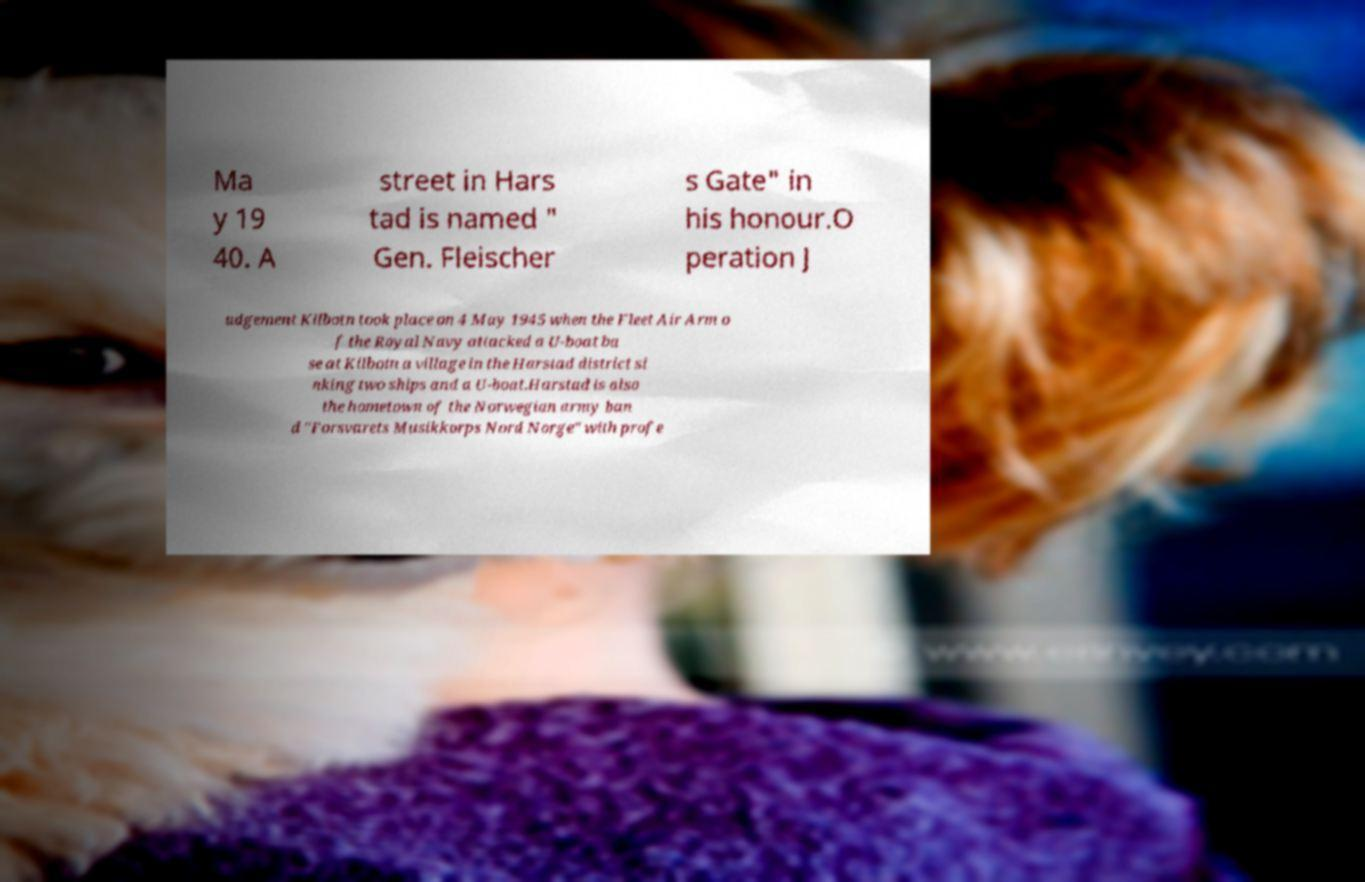Can you accurately transcribe the text from the provided image for me? Ma y 19 40. A street in Hars tad is named " Gen. Fleischer s Gate" in his honour.O peration J udgement Kilbotn took place on 4 May 1945 when the Fleet Air Arm o f the Royal Navy attacked a U-boat ba se at Kilbotn a village in the Harstad district si nking two ships and a U-boat.Harstad is also the hometown of the Norwegian army ban d "Forsvarets Musikkorps Nord Norge" with profe 